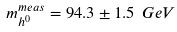<formula> <loc_0><loc_0><loc_500><loc_500>m _ { h ^ { 0 } } ^ { m e a s } = 9 4 . 3 \pm 1 . 5 \ G e V</formula> 